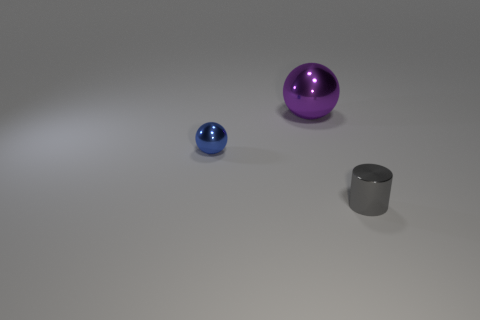Add 1 metal balls. How many objects exist? 4 Subtract all balls. How many objects are left? 1 Subtract 0 red spheres. How many objects are left? 3 Subtract all gray objects. Subtract all cylinders. How many objects are left? 1 Add 1 large spheres. How many large spheres are left? 2 Add 2 gray shiny objects. How many gray shiny objects exist? 3 